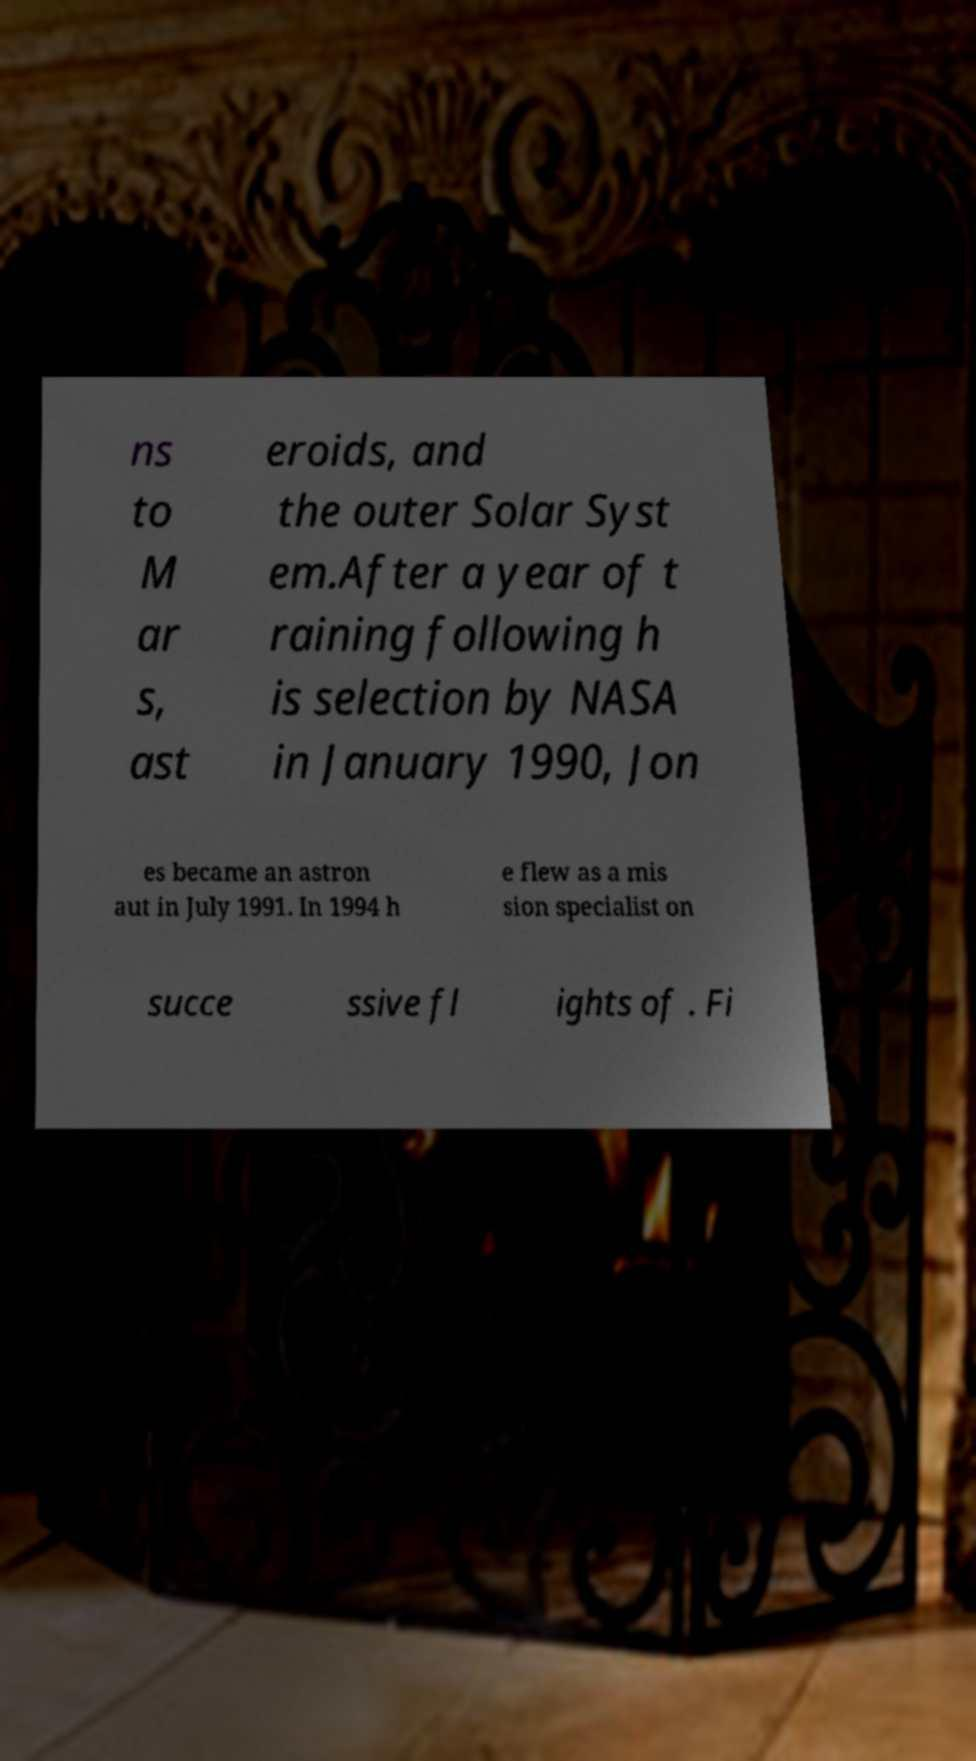Could you assist in decoding the text presented in this image and type it out clearly? ns to M ar s, ast eroids, and the outer Solar Syst em.After a year of t raining following h is selection by NASA in January 1990, Jon es became an astron aut in July 1991. In 1994 h e flew as a mis sion specialist on succe ssive fl ights of . Fi 